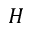Convert formula to latex. <formula><loc_0><loc_0><loc_500><loc_500>H</formula> 